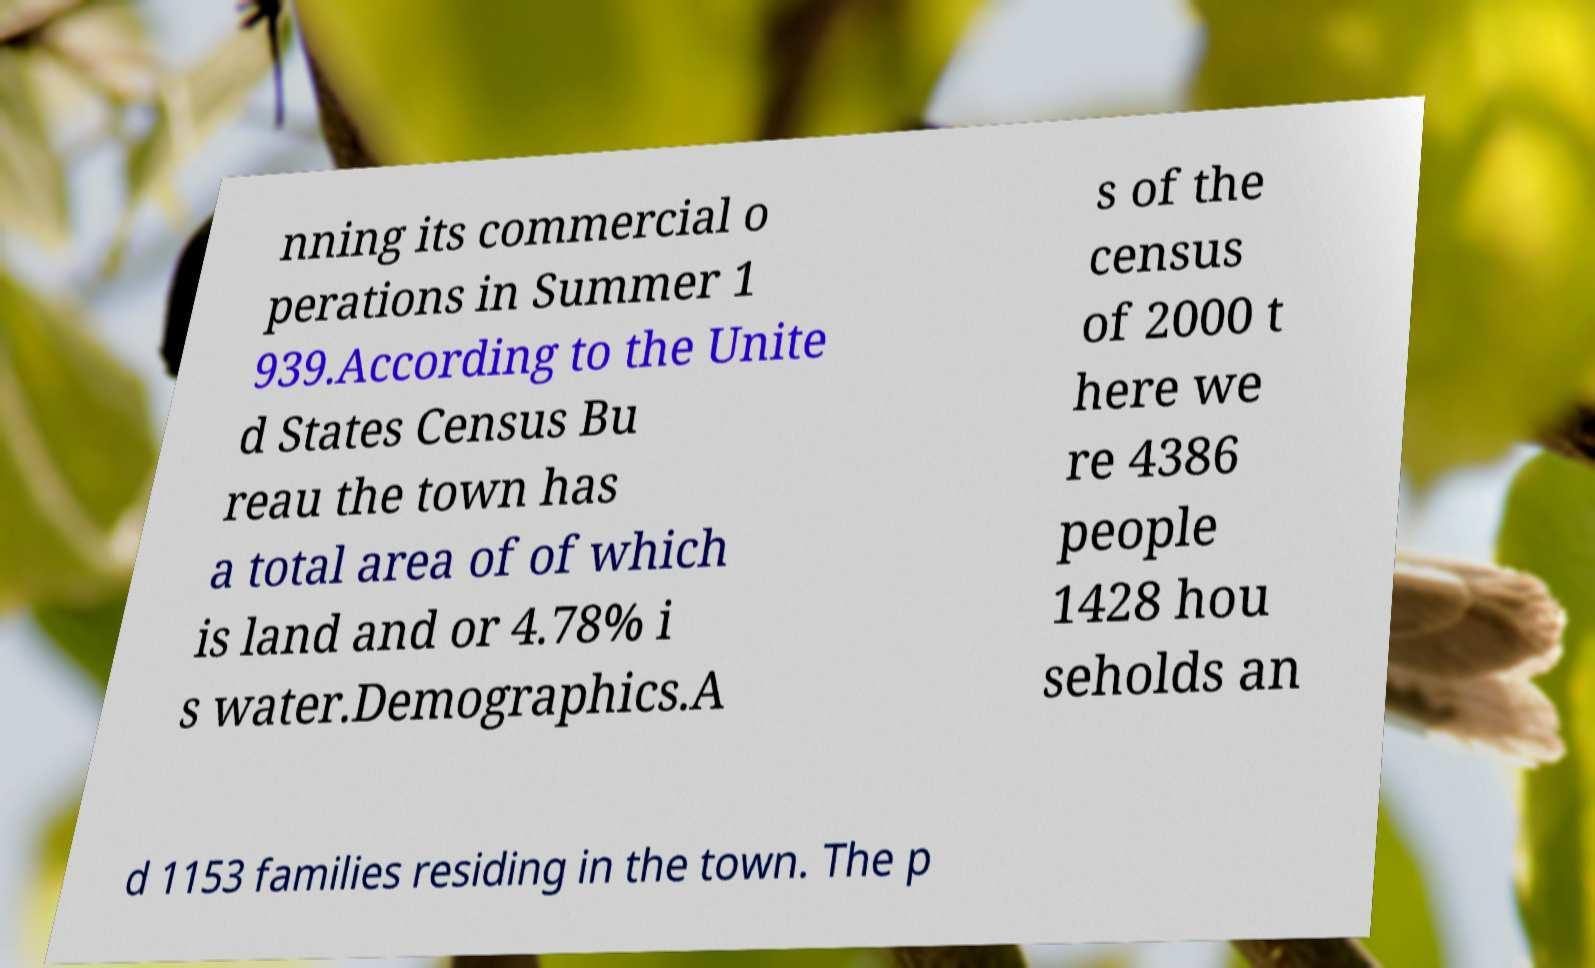What messages or text are displayed in this image? I need them in a readable, typed format. nning its commercial o perations in Summer 1 939.According to the Unite d States Census Bu reau the town has a total area of of which is land and or 4.78% i s water.Demographics.A s of the census of 2000 t here we re 4386 people 1428 hou seholds an d 1153 families residing in the town. The p 